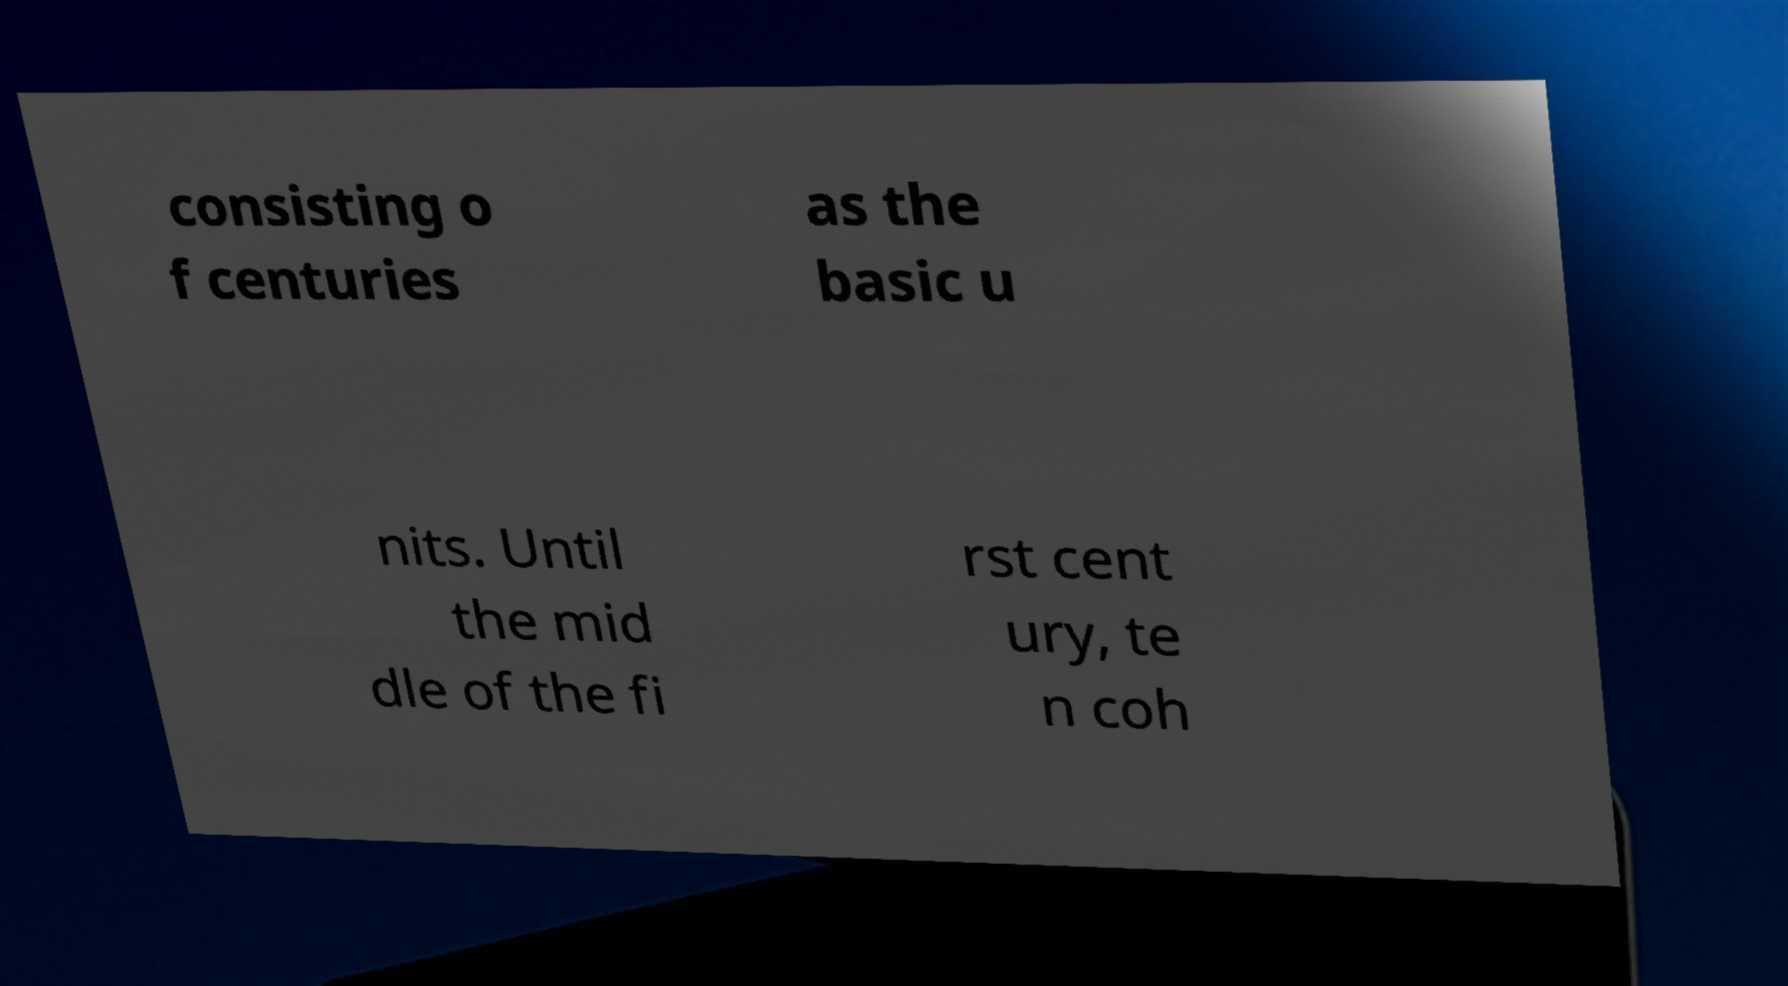Could you assist in decoding the text presented in this image and type it out clearly? consisting o f centuries as the basic u nits. Until the mid dle of the fi rst cent ury, te n coh 